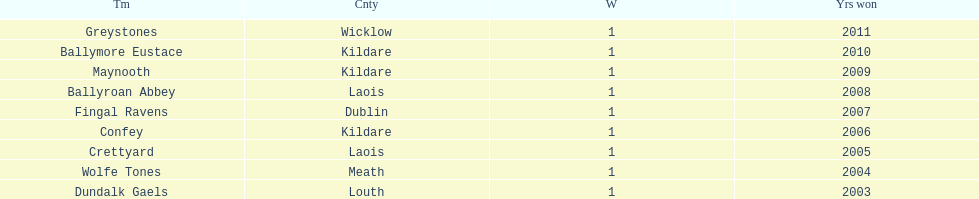Can you identify the initial team presented in the chart? Greystones. Parse the full table. {'header': ['Tm', 'Cnty', 'W', 'Yrs won'], 'rows': [['Greystones', 'Wicklow', '1', '2011'], ['Ballymore Eustace', 'Kildare', '1', '2010'], ['Maynooth', 'Kildare', '1', '2009'], ['Ballyroan Abbey', 'Laois', '1', '2008'], ['Fingal Ravens', 'Dublin', '1', '2007'], ['Confey', 'Kildare', '1', '2006'], ['Crettyard', 'Laois', '1', '2005'], ['Wolfe Tones', 'Meath', '1', '2004'], ['Dundalk Gaels', 'Louth', '1', '2003']]} 